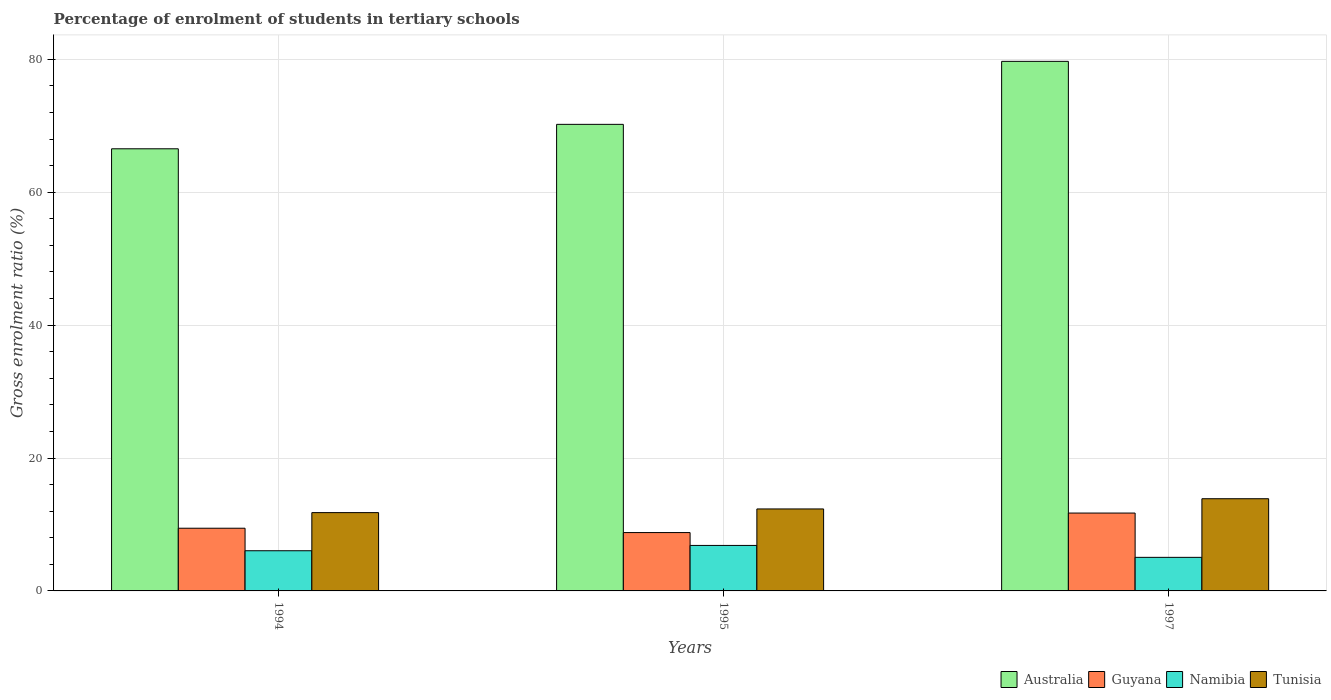How many different coloured bars are there?
Offer a very short reply. 4. How many groups of bars are there?
Offer a very short reply. 3. Are the number of bars per tick equal to the number of legend labels?
Your answer should be very brief. Yes. What is the label of the 1st group of bars from the left?
Your answer should be very brief. 1994. What is the percentage of students enrolled in tertiary schools in Australia in 1995?
Your answer should be compact. 70.21. Across all years, what is the maximum percentage of students enrolled in tertiary schools in Guyana?
Provide a succinct answer. 11.72. Across all years, what is the minimum percentage of students enrolled in tertiary schools in Guyana?
Your answer should be very brief. 8.78. In which year was the percentage of students enrolled in tertiary schools in Tunisia maximum?
Ensure brevity in your answer.  1997. In which year was the percentage of students enrolled in tertiary schools in Namibia minimum?
Make the answer very short. 1997. What is the total percentage of students enrolled in tertiary schools in Tunisia in the graph?
Provide a short and direct response. 37.99. What is the difference between the percentage of students enrolled in tertiary schools in Guyana in 1994 and that in 1995?
Offer a very short reply. 0.65. What is the difference between the percentage of students enrolled in tertiary schools in Guyana in 1997 and the percentage of students enrolled in tertiary schools in Australia in 1995?
Your answer should be compact. -58.49. What is the average percentage of students enrolled in tertiary schools in Australia per year?
Provide a short and direct response. 72.14. In the year 1995, what is the difference between the percentage of students enrolled in tertiary schools in Guyana and percentage of students enrolled in tertiary schools in Namibia?
Give a very brief answer. 1.93. What is the ratio of the percentage of students enrolled in tertiary schools in Australia in 1995 to that in 1997?
Make the answer very short. 0.88. What is the difference between the highest and the second highest percentage of students enrolled in tertiary schools in Australia?
Make the answer very short. 9.48. What is the difference between the highest and the lowest percentage of students enrolled in tertiary schools in Tunisia?
Offer a very short reply. 2.09. Is the sum of the percentage of students enrolled in tertiary schools in Tunisia in 1994 and 1995 greater than the maximum percentage of students enrolled in tertiary schools in Australia across all years?
Ensure brevity in your answer.  No. Is it the case that in every year, the sum of the percentage of students enrolled in tertiary schools in Australia and percentage of students enrolled in tertiary schools in Guyana is greater than the sum of percentage of students enrolled in tertiary schools in Tunisia and percentage of students enrolled in tertiary schools in Namibia?
Keep it short and to the point. Yes. What does the 3rd bar from the left in 1995 represents?
Offer a very short reply. Namibia. What does the 1st bar from the right in 1994 represents?
Provide a short and direct response. Tunisia. Is it the case that in every year, the sum of the percentage of students enrolled in tertiary schools in Tunisia and percentage of students enrolled in tertiary schools in Guyana is greater than the percentage of students enrolled in tertiary schools in Australia?
Your answer should be very brief. No. Are the values on the major ticks of Y-axis written in scientific E-notation?
Provide a succinct answer. No. Does the graph contain any zero values?
Your response must be concise. No. How many legend labels are there?
Keep it short and to the point. 4. What is the title of the graph?
Give a very brief answer. Percentage of enrolment of students in tertiary schools. Does "Turkmenistan" appear as one of the legend labels in the graph?
Your answer should be compact. No. What is the label or title of the X-axis?
Give a very brief answer. Years. What is the label or title of the Y-axis?
Keep it short and to the point. Gross enrolment ratio (%). What is the Gross enrolment ratio (%) in Australia in 1994?
Provide a short and direct response. 66.53. What is the Gross enrolment ratio (%) in Guyana in 1994?
Keep it short and to the point. 9.43. What is the Gross enrolment ratio (%) of Namibia in 1994?
Make the answer very short. 6.05. What is the Gross enrolment ratio (%) in Tunisia in 1994?
Provide a short and direct response. 11.78. What is the Gross enrolment ratio (%) of Australia in 1995?
Give a very brief answer. 70.21. What is the Gross enrolment ratio (%) of Guyana in 1995?
Your answer should be very brief. 8.78. What is the Gross enrolment ratio (%) of Namibia in 1995?
Make the answer very short. 6.85. What is the Gross enrolment ratio (%) of Tunisia in 1995?
Make the answer very short. 12.34. What is the Gross enrolment ratio (%) in Australia in 1997?
Make the answer very short. 79.69. What is the Gross enrolment ratio (%) in Guyana in 1997?
Provide a short and direct response. 11.72. What is the Gross enrolment ratio (%) of Namibia in 1997?
Offer a very short reply. 5.05. What is the Gross enrolment ratio (%) of Tunisia in 1997?
Offer a terse response. 13.87. Across all years, what is the maximum Gross enrolment ratio (%) in Australia?
Provide a short and direct response. 79.69. Across all years, what is the maximum Gross enrolment ratio (%) of Guyana?
Make the answer very short. 11.72. Across all years, what is the maximum Gross enrolment ratio (%) of Namibia?
Give a very brief answer. 6.85. Across all years, what is the maximum Gross enrolment ratio (%) in Tunisia?
Ensure brevity in your answer.  13.87. Across all years, what is the minimum Gross enrolment ratio (%) in Australia?
Make the answer very short. 66.53. Across all years, what is the minimum Gross enrolment ratio (%) of Guyana?
Offer a terse response. 8.78. Across all years, what is the minimum Gross enrolment ratio (%) of Namibia?
Make the answer very short. 5.05. Across all years, what is the minimum Gross enrolment ratio (%) of Tunisia?
Offer a terse response. 11.78. What is the total Gross enrolment ratio (%) of Australia in the graph?
Your answer should be very brief. 216.43. What is the total Gross enrolment ratio (%) in Guyana in the graph?
Your answer should be very brief. 29.93. What is the total Gross enrolment ratio (%) in Namibia in the graph?
Your response must be concise. 17.94. What is the total Gross enrolment ratio (%) of Tunisia in the graph?
Give a very brief answer. 37.99. What is the difference between the Gross enrolment ratio (%) in Australia in 1994 and that in 1995?
Ensure brevity in your answer.  -3.68. What is the difference between the Gross enrolment ratio (%) in Guyana in 1994 and that in 1995?
Provide a succinct answer. 0.65. What is the difference between the Gross enrolment ratio (%) of Namibia in 1994 and that in 1995?
Your answer should be very brief. -0.8. What is the difference between the Gross enrolment ratio (%) of Tunisia in 1994 and that in 1995?
Give a very brief answer. -0.55. What is the difference between the Gross enrolment ratio (%) of Australia in 1994 and that in 1997?
Offer a very short reply. -13.16. What is the difference between the Gross enrolment ratio (%) in Guyana in 1994 and that in 1997?
Ensure brevity in your answer.  -2.28. What is the difference between the Gross enrolment ratio (%) in Tunisia in 1994 and that in 1997?
Your answer should be very brief. -2.09. What is the difference between the Gross enrolment ratio (%) in Australia in 1995 and that in 1997?
Your response must be concise. -9.48. What is the difference between the Gross enrolment ratio (%) in Guyana in 1995 and that in 1997?
Your answer should be compact. -2.94. What is the difference between the Gross enrolment ratio (%) of Namibia in 1995 and that in 1997?
Offer a terse response. 1.8. What is the difference between the Gross enrolment ratio (%) in Tunisia in 1995 and that in 1997?
Provide a short and direct response. -1.54. What is the difference between the Gross enrolment ratio (%) of Australia in 1994 and the Gross enrolment ratio (%) of Guyana in 1995?
Keep it short and to the point. 57.75. What is the difference between the Gross enrolment ratio (%) of Australia in 1994 and the Gross enrolment ratio (%) of Namibia in 1995?
Your response must be concise. 59.68. What is the difference between the Gross enrolment ratio (%) of Australia in 1994 and the Gross enrolment ratio (%) of Tunisia in 1995?
Provide a short and direct response. 54.19. What is the difference between the Gross enrolment ratio (%) in Guyana in 1994 and the Gross enrolment ratio (%) in Namibia in 1995?
Offer a very short reply. 2.59. What is the difference between the Gross enrolment ratio (%) of Guyana in 1994 and the Gross enrolment ratio (%) of Tunisia in 1995?
Make the answer very short. -2.9. What is the difference between the Gross enrolment ratio (%) of Namibia in 1994 and the Gross enrolment ratio (%) of Tunisia in 1995?
Your response must be concise. -6.29. What is the difference between the Gross enrolment ratio (%) of Australia in 1994 and the Gross enrolment ratio (%) of Guyana in 1997?
Your answer should be compact. 54.81. What is the difference between the Gross enrolment ratio (%) of Australia in 1994 and the Gross enrolment ratio (%) of Namibia in 1997?
Your response must be concise. 61.48. What is the difference between the Gross enrolment ratio (%) in Australia in 1994 and the Gross enrolment ratio (%) in Tunisia in 1997?
Your answer should be very brief. 52.66. What is the difference between the Gross enrolment ratio (%) of Guyana in 1994 and the Gross enrolment ratio (%) of Namibia in 1997?
Offer a very short reply. 4.38. What is the difference between the Gross enrolment ratio (%) of Guyana in 1994 and the Gross enrolment ratio (%) of Tunisia in 1997?
Your answer should be very brief. -4.44. What is the difference between the Gross enrolment ratio (%) in Namibia in 1994 and the Gross enrolment ratio (%) in Tunisia in 1997?
Make the answer very short. -7.83. What is the difference between the Gross enrolment ratio (%) in Australia in 1995 and the Gross enrolment ratio (%) in Guyana in 1997?
Make the answer very short. 58.49. What is the difference between the Gross enrolment ratio (%) in Australia in 1995 and the Gross enrolment ratio (%) in Namibia in 1997?
Keep it short and to the point. 65.16. What is the difference between the Gross enrolment ratio (%) in Australia in 1995 and the Gross enrolment ratio (%) in Tunisia in 1997?
Keep it short and to the point. 56.34. What is the difference between the Gross enrolment ratio (%) in Guyana in 1995 and the Gross enrolment ratio (%) in Namibia in 1997?
Your answer should be compact. 3.73. What is the difference between the Gross enrolment ratio (%) of Guyana in 1995 and the Gross enrolment ratio (%) of Tunisia in 1997?
Offer a very short reply. -5.09. What is the difference between the Gross enrolment ratio (%) of Namibia in 1995 and the Gross enrolment ratio (%) of Tunisia in 1997?
Your answer should be compact. -7.03. What is the average Gross enrolment ratio (%) of Australia per year?
Provide a succinct answer. 72.14. What is the average Gross enrolment ratio (%) in Guyana per year?
Offer a very short reply. 9.98. What is the average Gross enrolment ratio (%) of Namibia per year?
Make the answer very short. 5.98. What is the average Gross enrolment ratio (%) in Tunisia per year?
Keep it short and to the point. 12.66. In the year 1994, what is the difference between the Gross enrolment ratio (%) of Australia and Gross enrolment ratio (%) of Guyana?
Make the answer very short. 57.1. In the year 1994, what is the difference between the Gross enrolment ratio (%) in Australia and Gross enrolment ratio (%) in Namibia?
Your answer should be compact. 60.48. In the year 1994, what is the difference between the Gross enrolment ratio (%) of Australia and Gross enrolment ratio (%) of Tunisia?
Provide a short and direct response. 54.75. In the year 1994, what is the difference between the Gross enrolment ratio (%) of Guyana and Gross enrolment ratio (%) of Namibia?
Your answer should be very brief. 3.39. In the year 1994, what is the difference between the Gross enrolment ratio (%) in Guyana and Gross enrolment ratio (%) in Tunisia?
Your response must be concise. -2.35. In the year 1994, what is the difference between the Gross enrolment ratio (%) of Namibia and Gross enrolment ratio (%) of Tunisia?
Your response must be concise. -5.74. In the year 1995, what is the difference between the Gross enrolment ratio (%) of Australia and Gross enrolment ratio (%) of Guyana?
Offer a terse response. 61.43. In the year 1995, what is the difference between the Gross enrolment ratio (%) of Australia and Gross enrolment ratio (%) of Namibia?
Make the answer very short. 63.36. In the year 1995, what is the difference between the Gross enrolment ratio (%) in Australia and Gross enrolment ratio (%) in Tunisia?
Offer a terse response. 57.87. In the year 1995, what is the difference between the Gross enrolment ratio (%) of Guyana and Gross enrolment ratio (%) of Namibia?
Keep it short and to the point. 1.93. In the year 1995, what is the difference between the Gross enrolment ratio (%) of Guyana and Gross enrolment ratio (%) of Tunisia?
Your response must be concise. -3.56. In the year 1995, what is the difference between the Gross enrolment ratio (%) of Namibia and Gross enrolment ratio (%) of Tunisia?
Your response must be concise. -5.49. In the year 1997, what is the difference between the Gross enrolment ratio (%) of Australia and Gross enrolment ratio (%) of Guyana?
Your response must be concise. 67.97. In the year 1997, what is the difference between the Gross enrolment ratio (%) of Australia and Gross enrolment ratio (%) of Namibia?
Provide a short and direct response. 74.64. In the year 1997, what is the difference between the Gross enrolment ratio (%) of Australia and Gross enrolment ratio (%) of Tunisia?
Ensure brevity in your answer.  65.81. In the year 1997, what is the difference between the Gross enrolment ratio (%) of Guyana and Gross enrolment ratio (%) of Namibia?
Make the answer very short. 6.67. In the year 1997, what is the difference between the Gross enrolment ratio (%) of Guyana and Gross enrolment ratio (%) of Tunisia?
Your answer should be compact. -2.16. In the year 1997, what is the difference between the Gross enrolment ratio (%) in Namibia and Gross enrolment ratio (%) in Tunisia?
Offer a terse response. -8.82. What is the ratio of the Gross enrolment ratio (%) of Australia in 1994 to that in 1995?
Ensure brevity in your answer.  0.95. What is the ratio of the Gross enrolment ratio (%) of Guyana in 1994 to that in 1995?
Provide a succinct answer. 1.07. What is the ratio of the Gross enrolment ratio (%) of Namibia in 1994 to that in 1995?
Make the answer very short. 0.88. What is the ratio of the Gross enrolment ratio (%) of Tunisia in 1994 to that in 1995?
Offer a very short reply. 0.96. What is the ratio of the Gross enrolment ratio (%) of Australia in 1994 to that in 1997?
Keep it short and to the point. 0.83. What is the ratio of the Gross enrolment ratio (%) of Guyana in 1994 to that in 1997?
Provide a succinct answer. 0.81. What is the ratio of the Gross enrolment ratio (%) of Namibia in 1994 to that in 1997?
Give a very brief answer. 1.2. What is the ratio of the Gross enrolment ratio (%) of Tunisia in 1994 to that in 1997?
Make the answer very short. 0.85. What is the ratio of the Gross enrolment ratio (%) of Australia in 1995 to that in 1997?
Your response must be concise. 0.88. What is the ratio of the Gross enrolment ratio (%) of Guyana in 1995 to that in 1997?
Ensure brevity in your answer.  0.75. What is the ratio of the Gross enrolment ratio (%) in Namibia in 1995 to that in 1997?
Your response must be concise. 1.36. What is the ratio of the Gross enrolment ratio (%) of Tunisia in 1995 to that in 1997?
Provide a succinct answer. 0.89. What is the difference between the highest and the second highest Gross enrolment ratio (%) in Australia?
Offer a very short reply. 9.48. What is the difference between the highest and the second highest Gross enrolment ratio (%) in Guyana?
Give a very brief answer. 2.28. What is the difference between the highest and the second highest Gross enrolment ratio (%) in Namibia?
Keep it short and to the point. 0.8. What is the difference between the highest and the second highest Gross enrolment ratio (%) in Tunisia?
Offer a very short reply. 1.54. What is the difference between the highest and the lowest Gross enrolment ratio (%) in Australia?
Your answer should be very brief. 13.16. What is the difference between the highest and the lowest Gross enrolment ratio (%) in Guyana?
Your answer should be compact. 2.94. What is the difference between the highest and the lowest Gross enrolment ratio (%) in Namibia?
Your response must be concise. 1.8. What is the difference between the highest and the lowest Gross enrolment ratio (%) of Tunisia?
Provide a short and direct response. 2.09. 